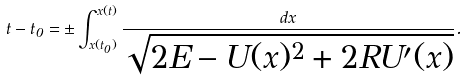<formula> <loc_0><loc_0><loc_500><loc_500>t - t _ { 0 } = \pm \int _ { x ( t _ { 0 } ) } ^ { x ( t ) } \frac { d x } { \sqrt { 2 E - U ( x ) ^ { 2 } + 2 R U ^ { \prime } ( x ) } } .</formula> 